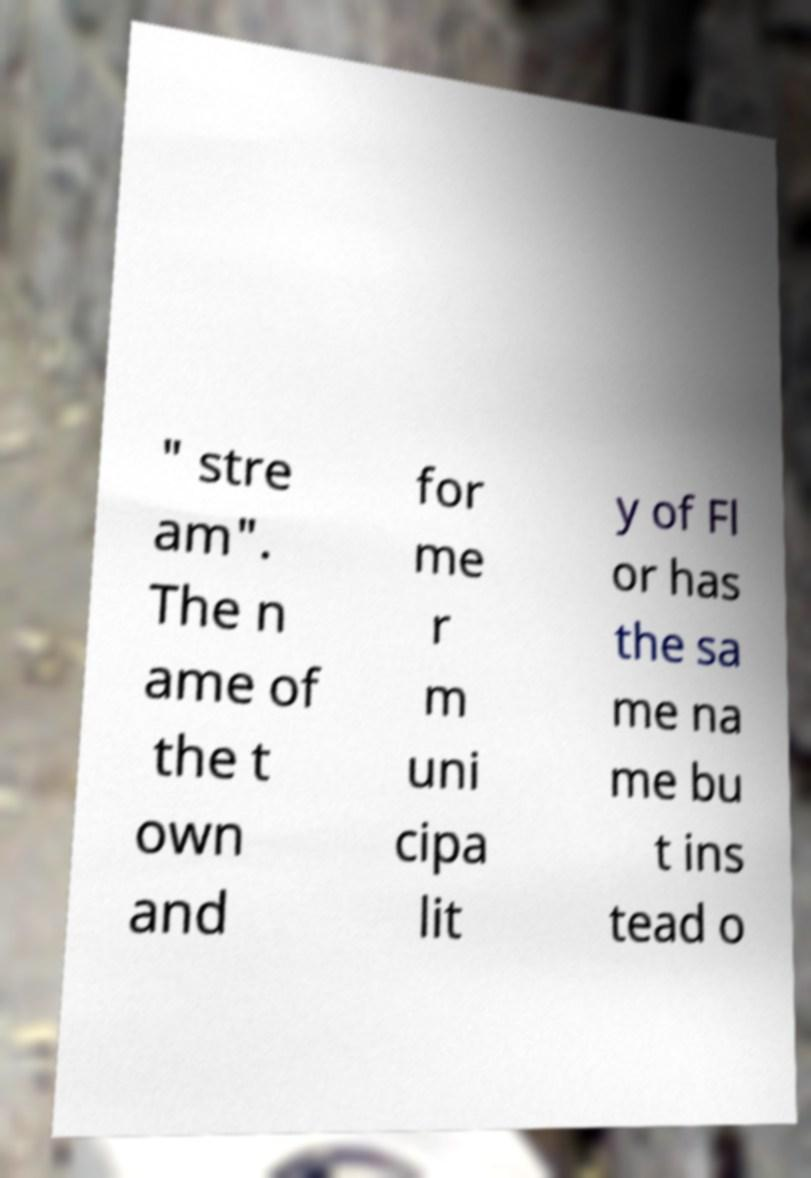For documentation purposes, I need the text within this image transcribed. Could you provide that? " stre am". The n ame of the t own and for me r m uni cipa lit y of Fl or has the sa me na me bu t ins tead o 